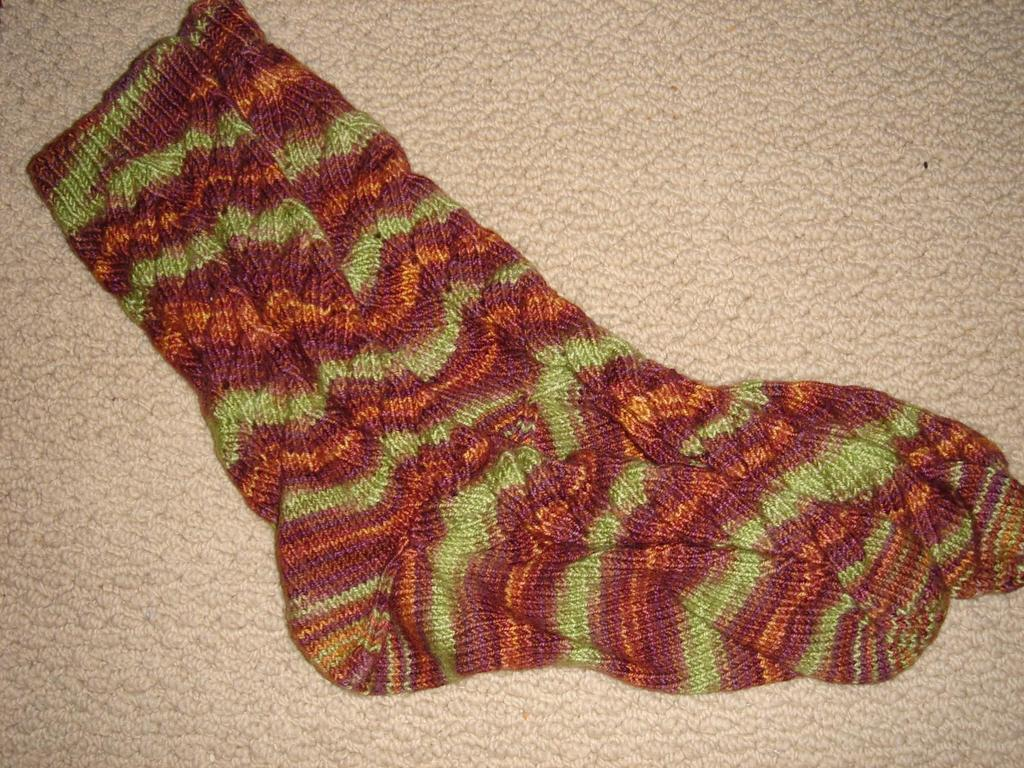What type of clothing item is present in the image? There is a pair of socks in the image. What can be said about the colors of the socks? The socks are in multiple colors. Where are the socks located in the image? The socks are on a surface. What type of stamp can be seen on the socks in the image? There is no stamp present on the socks in the image. How many cans of soda are visible in the image? There are no cans of soda present in the image. 